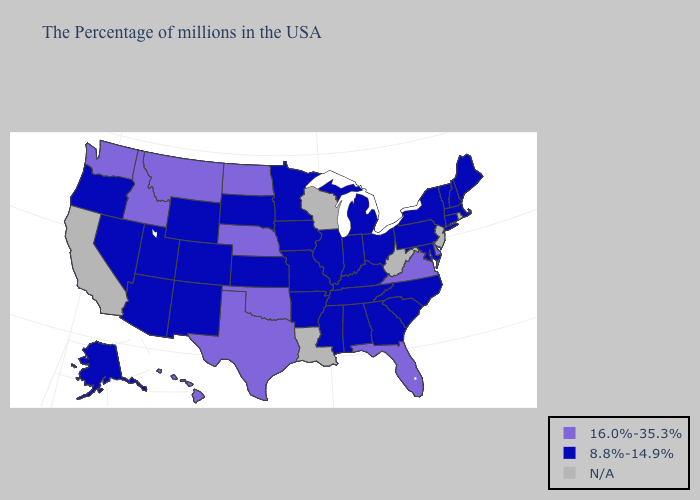What is the value of Maine?
Answer briefly. 8.8%-14.9%. Name the states that have a value in the range 8.8%-14.9%?
Short answer required. Maine, Massachusetts, New Hampshire, Vermont, Connecticut, New York, Maryland, Pennsylvania, North Carolina, South Carolina, Ohio, Georgia, Michigan, Kentucky, Indiana, Alabama, Tennessee, Illinois, Mississippi, Missouri, Arkansas, Minnesota, Iowa, Kansas, South Dakota, Wyoming, Colorado, New Mexico, Utah, Arizona, Nevada, Oregon, Alaska. What is the highest value in the USA?
Write a very short answer. 16.0%-35.3%. What is the lowest value in states that border Georgia?
Give a very brief answer. 8.8%-14.9%. What is the highest value in states that border Wyoming?
Concise answer only. 16.0%-35.3%. Name the states that have a value in the range 16.0%-35.3%?
Write a very short answer. Delaware, Virginia, Florida, Nebraska, Oklahoma, Texas, North Dakota, Montana, Idaho, Washington, Hawaii. Among the states that border Alabama , which have the lowest value?
Keep it brief. Georgia, Tennessee, Mississippi. Among the states that border Kentucky , which have the highest value?
Keep it brief. Virginia. What is the value of Kentucky?
Concise answer only. 8.8%-14.9%. What is the value of Nevada?
Answer briefly. 8.8%-14.9%. How many symbols are there in the legend?
Answer briefly. 3. What is the lowest value in the USA?
Quick response, please. 8.8%-14.9%. Among the states that border North Dakota , which have the highest value?
Be succinct. Montana. 